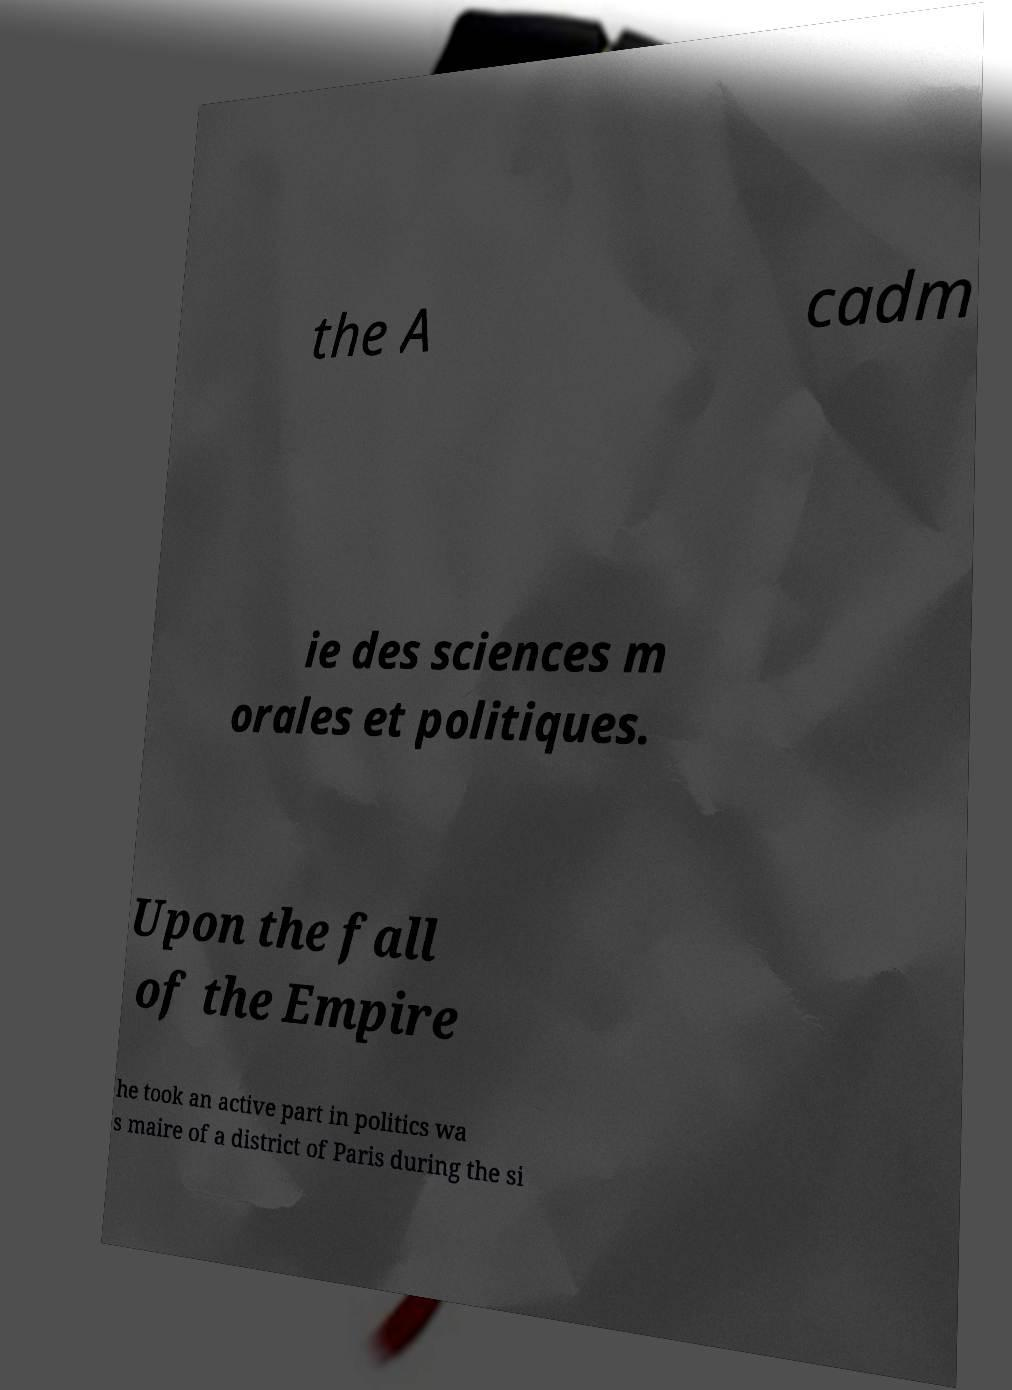What messages or text are displayed in this image? I need them in a readable, typed format. the A cadm ie des sciences m orales et politiques. Upon the fall of the Empire he took an active part in politics wa s maire of a district of Paris during the si 